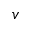Convert formula to latex. <formula><loc_0><loc_0><loc_500><loc_500>v</formula> 